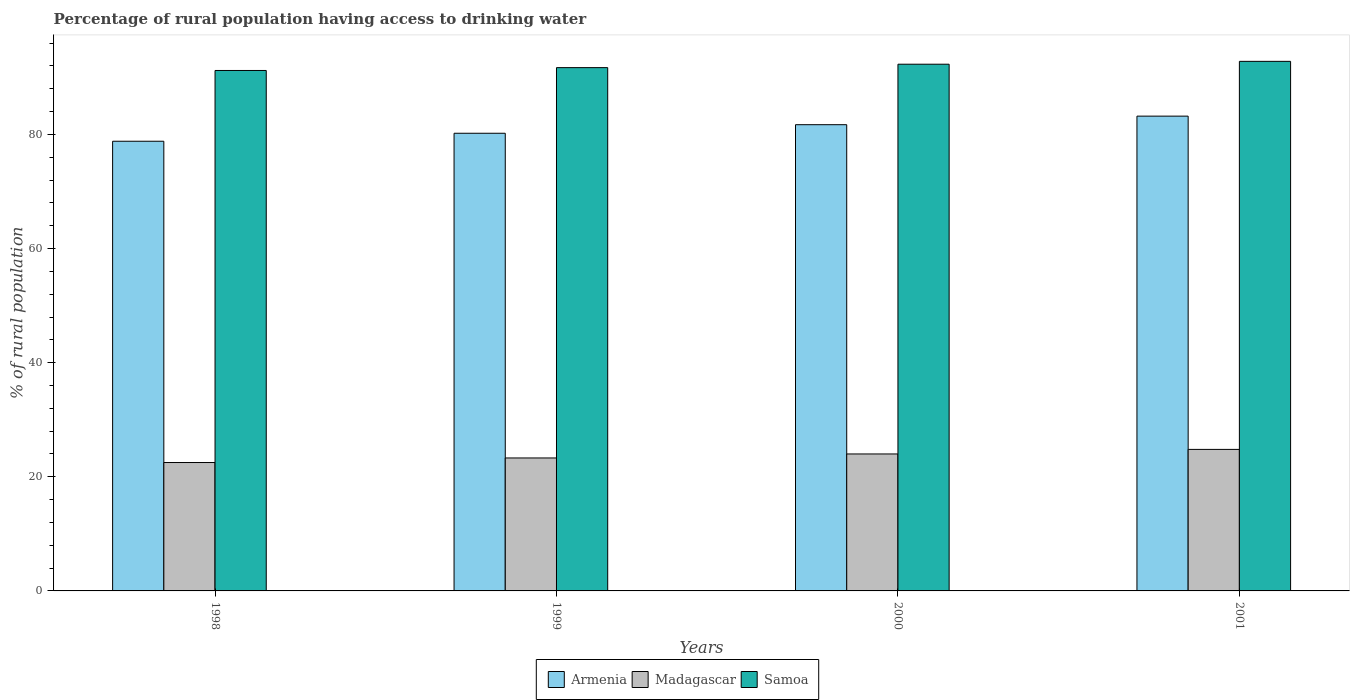How many bars are there on the 4th tick from the right?
Provide a short and direct response. 3. In how many cases, is the number of bars for a given year not equal to the number of legend labels?
Your response must be concise. 0. What is the percentage of rural population having access to drinking water in Samoa in 2000?
Ensure brevity in your answer.  92.3. Across all years, what is the maximum percentage of rural population having access to drinking water in Armenia?
Keep it short and to the point. 83.2. Across all years, what is the minimum percentage of rural population having access to drinking water in Armenia?
Give a very brief answer. 78.8. In which year was the percentage of rural population having access to drinking water in Madagascar minimum?
Provide a short and direct response. 1998. What is the total percentage of rural population having access to drinking water in Samoa in the graph?
Offer a very short reply. 368. What is the average percentage of rural population having access to drinking water in Madagascar per year?
Your response must be concise. 23.65. In the year 1999, what is the difference between the percentage of rural population having access to drinking water in Samoa and percentage of rural population having access to drinking water in Armenia?
Keep it short and to the point. 11.5. In how many years, is the percentage of rural population having access to drinking water in Samoa greater than 64 %?
Your answer should be very brief. 4. What is the ratio of the percentage of rural population having access to drinking water in Armenia in 1998 to that in 2001?
Your response must be concise. 0.95. Is the percentage of rural population having access to drinking water in Armenia in 1998 less than that in 2000?
Make the answer very short. Yes. What is the difference between the highest and the second highest percentage of rural population having access to drinking water in Samoa?
Make the answer very short. 0.5. What is the difference between the highest and the lowest percentage of rural population having access to drinking water in Samoa?
Ensure brevity in your answer.  1.6. In how many years, is the percentage of rural population having access to drinking water in Samoa greater than the average percentage of rural population having access to drinking water in Samoa taken over all years?
Provide a succinct answer. 2. Is the sum of the percentage of rural population having access to drinking water in Armenia in 1998 and 2001 greater than the maximum percentage of rural population having access to drinking water in Madagascar across all years?
Offer a terse response. Yes. What does the 1st bar from the left in 2000 represents?
Provide a succinct answer. Armenia. What does the 2nd bar from the right in 1998 represents?
Provide a short and direct response. Madagascar. How many bars are there?
Ensure brevity in your answer.  12. Are the values on the major ticks of Y-axis written in scientific E-notation?
Provide a succinct answer. No. Does the graph contain any zero values?
Your response must be concise. No. Does the graph contain grids?
Ensure brevity in your answer.  No. How many legend labels are there?
Keep it short and to the point. 3. How are the legend labels stacked?
Ensure brevity in your answer.  Horizontal. What is the title of the graph?
Ensure brevity in your answer.  Percentage of rural population having access to drinking water. Does "United Kingdom" appear as one of the legend labels in the graph?
Your answer should be compact. No. What is the label or title of the X-axis?
Provide a succinct answer. Years. What is the label or title of the Y-axis?
Give a very brief answer. % of rural population. What is the % of rural population of Armenia in 1998?
Offer a terse response. 78.8. What is the % of rural population of Madagascar in 1998?
Provide a succinct answer. 22.5. What is the % of rural population of Samoa in 1998?
Your response must be concise. 91.2. What is the % of rural population of Armenia in 1999?
Your answer should be very brief. 80.2. What is the % of rural population in Madagascar in 1999?
Provide a short and direct response. 23.3. What is the % of rural population of Samoa in 1999?
Give a very brief answer. 91.7. What is the % of rural population of Armenia in 2000?
Your answer should be very brief. 81.7. What is the % of rural population of Samoa in 2000?
Your answer should be compact. 92.3. What is the % of rural population in Armenia in 2001?
Ensure brevity in your answer.  83.2. What is the % of rural population of Madagascar in 2001?
Give a very brief answer. 24.8. What is the % of rural population in Samoa in 2001?
Your answer should be compact. 92.8. Across all years, what is the maximum % of rural population in Armenia?
Give a very brief answer. 83.2. Across all years, what is the maximum % of rural population of Madagascar?
Provide a succinct answer. 24.8. Across all years, what is the maximum % of rural population in Samoa?
Offer a terse response. 92.8. Across all years, what is the minimum % of rural population in Armenia?
Your answer should be compact. 78.8. Across all years, what is the minimum % of rural population of Samoa?
Keep it short and to the point. 91.2. What is the total % of rural population of Armenia in the graph?
Provide a succinct answer. 323.9. What is the total % of rural population in Madagascar in the graph?
Your response must be concise. 94.6. What is the total % of rural population of Samoa in the graph?
Provide a short and direct response. 368. What is the difference between the % of rural population of Samoa in 1998 and that in 1999?
Make the answer very short. -0.5. What is the difference between the % of rural population in Armenia in 1998 and that in 2000?
Offer a terse response. -2.9. What is the difference between the % of rural population of Armenia in 1998 and that in 2001?
Your response must be concise. -4.4. What is the difference between the % of rural population of Samoa in 1998 and that in 2001?
Provide a short and direct response. -1.6. What is the difference between the % of rural population of Armenia in 1999 and that in 2001?
Give a very brief answer. -3. What is the difference between the % of rural population in Madagascar in 1999 and that in 2001?
Provide a short and direct response. -1.5. What is the difference between the % of rural population in Armenia in 2000 and that in 2001?
Your answer should be very brief. -1.5. What is the difference between the % of rural population in Madagascar in 2000 and that in 2001?
Offer a terse response. -0.8. What is the difference between the % of rural population in Armenia in 1998 and the % of rural population in Madagascar in 1999?
Offer a terse response. 55.5. What is the difference between the % of rural population in Madagascar in 1998 and the % of rural population in Samoa in 1999?
Your response must be concise. -69.2. What is the difference between the % of rural population in Armenia in 1998 and the % of rural population in Madagascar in 2000?
Your response must be concise. 54.8. What is the difference between the % of rural population in Madagascar in 1998 and the % of rural population in Samoa in 2000?
Your answer should be compact. -69.8. What is the difference between the % of rural population of Armenia in 1998 and the % of rural population of Samoa in 2001?
Your answer should be very brief. -14. What is the difference between the % of rural population of Madagascar in 1998 and the % of rural population of Samoa in 2001?
Offer a very short reply. -70.3. What is the difference between the % of rural population of Armenia in 1999 and the % of rural population of Madagascar in 2000?
Your answer should be compact. 56.2. What is the difference between the % of rural population in Madagascar in 1999 and the % of rural population in Samoa in 2000?
Make the answer very short. -69. What is the difference between the % of rural population in Armenia in 1999 and the % of rural population in Madagascar in 2001?
Give a very brief answer. 55.4. What is the difference between the % of rural population in Armenia in 1999 and the % of rural population in Samoa in 2001?
Give a very brief answer. -12.6. What is the difference between the % of rural population of Madagascar in 1999 and the % of rural population of Samoa in 2001?
Make the answer very short. -69.5. What is the difference between the % of rural population of Armenia in 2000 and the % of rural population of Madagascar in 2001?
Offer a terse response. 56.9. What is the difference between the % of rural population of Madagascar in 2000 and the % of rural population of Samoa in 2001?
Ensure brevity in your answer.  -68.8. What is the average % of rural population in Armenia per year?
Your answer should be very brief. 80.97. What is the average % of rural population of Madagascar per year?
Your response must be concise. 23.65. What is the average % of rural population in Samoa per year?
Offer a terse response. 92. In the year 1998, what is the difference between the % of rural population in Armenia and % of rural population in Madagascar?
Make the answer very short. 56.3. In the year 1998, what is the difference between the % of rural population of Madagascar and % of rural population of Samoa?
Ensure brevity in your answer.  -68.7. In the year 1999, what is the difference between the % of rural population of Armenia and % of rural population of Madagascar?
Offer a very short reply. 56.9. In the year 1999, what is the difference between the % of rural population in Armenia and % of rural population in Samoa?
Your answer should be very brief. -11.5. In the year 1999, what is the difference between the % of rural population of Madagascar and % of rural population of Samoa?
Make the answer very short. -68.4. In the year 2000, what is the difference between the % of rural population of Armenia and % of rural population of Madagascar?
Provide a succinct answer. 57.7. In the year 2000, what is the difference between the % of rural population of Armenia and % of rural population of Samoa?
Your response must be concise. -10.6. In the year 2000, what is the difference between the % of rural population in Madagascar and % of rural population in Samoa?
Ensure brevity in your answer.  -68.3. In the year 2001, what is the difference between the % of rural population of Armenia and % of rural population of Madagascar?
Your answer should be very brief. 58.4. In the year 2001, what is the difference between the % of rural population in Madagascar and % of rural population in Samoa?
Your answer should be compact. -68. What is the ratio of the % of rural population of Armenia in 1998 to that in 1999?
Your response must be concise. 0.98. What is the ratio of the % of rural population in Madagascar in 1998 to that in 1999?
Give a very brief answer. 0.97. What is the ratio of the % of rural population in Armenia in 1998 to that in 2000?
Keep it short and to the point. 0.96. What is the ratio of the % of rural population of Madagascar in 1998 to that in 2000?
Provide a short and direct response. 0.94. What is the ratio of the % of rural population in Armenia in 1998 to that in 2001?
Keep it short and to the point. 0.95. What is the ratio of the % of rural population of Madagascar in 1998 to that in 2001?
Ensure brevity in your answer.  0.91. What is the ratio of the % of rural population of Samoa in 1998 to that in 2001?
Provide a short and direct response. 0.98. What is the ratio of the % of rural population of Armenia in 1999 to that in 2000?
Make the answer very short. 0.98. What is the ratio of the % of rural population of Madagascar in 1999 to that in 2000?
Your answer should be very brief. 0.97. What is the ratio of the % of rural population in Armenia in 1999 to that in 2001?
Provide a short and direct response. 0.96. What is the ratio of the % of rural population in Madagascar in 1999 to that in 2001?
Your answer should be compact. 0.94. What is the ratio of the % of rural population in Armenia in 2000 to that in 2001?
Make the answer very short. 0.98. What is the difference between the highest and the second highest % of rural population in Armenia?
Your answer should be compact. 1.5. What is the difference between the highest and the second highest % of rural population of Samoa?
Your answer should be compact. 0.5. What is the difference between the highest and the lowest % of rural population of Madagascar?
Your answer should be compact. 2.3. What is the difference between the highest and the lowest % of rural population in Samoa?
Ensure brevity in your answer.  1.6. 